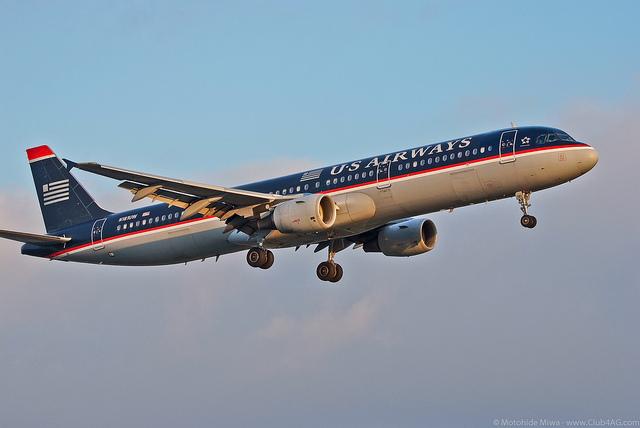What is in the sky?
Short answer required. Airplane. Is the plane flying?
Concise answer only. Yes. Is the airplane landing?
Short answer required. No. What is the airline?
Quick response, please. Us airways. Which airline is this?
Answer briefly. Us airways. Which airline does this plane belong to?
Give a very brief answer. Us airways. What color is the plane?
Answer briefly. Blue and gray. What airline is this?
Quick response, please. Us airways. What is the majority color of the plane?
Write a very short answer. Blue. What color is the top stripe on the plane?
Short answer required. Red. 